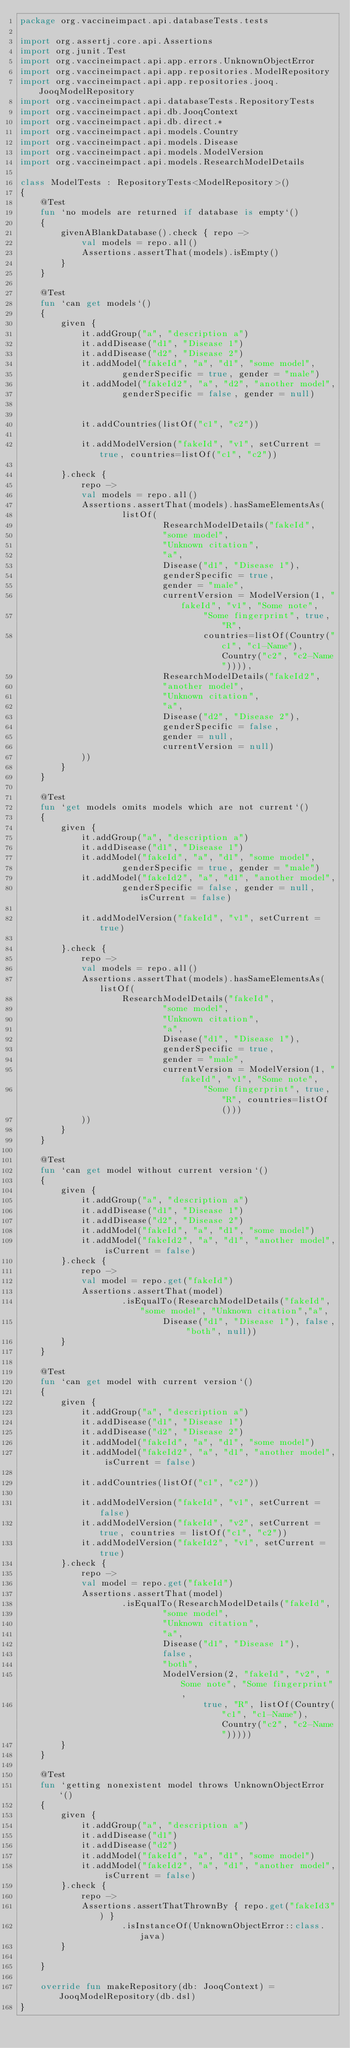<code> <loc_0><loc_0><loc_500><loc_500><_Kotlin_>package org.vaccineimpact.api.databaseTests.tests

import org.assertj.core.api.Assertions
import org.junit.Test
import org.vaccineimpact.api.app.errors.UnknownObjectError
import org.vaccineimpact.api.app.repositories.ModelRepository
import org.vaccineimpact.api.app.repositories.jooq.JooqModelRepository
import org.vaccineimpact.api.databaseTests.RepositoryTests
import org.vaccineimpact.api.db.JooqContext
import org.vaccineimpact.api.db.direct.*
import org.vaccineimpact.api.models.Country
import org.vaccineimpact.api.models.Disease
import org.vaccineimpact.api.models.ModelVersion
import org.vaccineimpact.api.models.ResearchModelDetails

class ModelTests : RepositoryTests<ModelRepository>()
{
    @Test
    fun `no models are returned if database is empty`()
    {
        givenABlankDatabase().check { repo ->
            val models = repo.all()
            Assertions.assertThat(models).isEmpty()
        }
    }

    @Test
    fun `can get models`()
    {
        given {
            it.addGroup("a", "description a")
            it.addDisease("d1", "Disease 1")
            it.addDisease("d2", "Disease 2")
            it.addModel("fakeId", "a", "d1", "some model",
                    genderSpecific = true, gender = "male")
            it.addModel("fakeId2", "a", "d2", "another model",
                    genderSpecific = false, gender = null)


            it.addCountries(listOf("c1", "c2"))

            it.addModelVersion("fakeId", "v1", setCurrent = true, countries=listOf("c1", "c2"))

        }.check {
            repo ->
            val models = repo.all()
            Assertions.assertThat(models).hasSameElementsAs(
                    listOf(
                            ResearchModelDetails("fakeId",
                            "some model",
                            "Unknown citation",
                            "a",
                            Disease("d1", "Disease 1"),
                            genderSpecific = true,
                            gender = "male",
                            currentVersion = ModelVersion(1, "fakeId", "v1", "Some note",
                                    "Some fingerprint", true, "R",
                                    countries=listOf(Country("c1", "c1-Name"), Country("c2", "c2-Name")))),
                            ResearchModelDetails("fakeId2",
                            "another model",
                            "Unknown citation",
                            "a",
                            Disease("d2", "Disease 2"),
                            genderSpecific = false,
                            gender = null,
                            currentVersion = null)
            ))
        }
    }

    @Test
    fun `get models omits models which are not current`()
    {
        given {
            it.addGroup("a", "description a")
            it.addDisease("d1", "Disease 1")
            it.addModel("fakeId", "a", "d1", "some model",
                    genderSpecific = true, gender = "male")
            it.addModel("fakeId2", "a", "d1", "another model",
                    genderSpecific = false, gender = null, isCurrent = false)

            it.addModelVersion("fakeId", "v1", setCurrent = true)

        }.check {
            repo ->
            val models = repo.all()
            Assertions.assertThat(models).hasSameElementsAs(listOf(
                    ResearchModelDetails("fakeId",
                            "some model",
                            "Unknown citation",
                            "a",
                            Disease("d1", "Disease 1"),
                            genderSpecific = true,
                            gender = "male",
                            currentVersion = ModelVersion(1, "fakeId", "v1", "Some note",
                                    "Some fingerprint", true, "R", countries=listOf()))
            ))
        }
    }

    @Test
    fun `can get model without current version`()
    {
        given {
            it.addGroup("a", "description a")
            it.addDisease("d1", "Disease 1")
            it.addDisease("d2", "Disease 2")
            it.addModel("fakeId", "a", "d1", "some model")
            it.addModel("fakeId2", "a", "d1", "another model", isCurrent = false)
        }.check {
            repo ->
            val model = repo.get("fakeId")
            Assertions.assertThat(model)
                    .isEqualTo(ResearchModelDetails("fakeId", "some model", "Unknown citation","a",
                            Disease("d1", "Disease 1"), false, "both", null))
        }
    }

    @Test
    fun `can get model with current version`()
    {
        given {
            it.addGroup("a", "description a")
            it.addDisease("d1", "Disease 1")
            it.addDisease("d2", "Disease 2")
            it.addModel("fakeId", "a", "d1", "some model")
            it.addModel("fakeId2", "a", "d1", "another model", isCurrent = false)

            it.addCountries(listOf("c1", "c2"))

            it.addModelVersion("fakeId", "v1", setCurrent = false)
            it.addModelVersion("fakeId", "v2", setCurrent = true, countries = listOf("c1", "c2"))
            it.addModelVersion("fakeId2", "v1", setCurrent = true)
        }.check {
            repo ->
            val model = repo.get("fakeId")
            Assertions.assertThat(model)
                    .isEqualTo(ResearchModelDetails("fakeId",
                            "some model",
                            "Unknown citation",
                            "a",
                            Disease("d1", "Disease 1"),
                            false,
                            "both",
                            ModelVersion(2, "fakeId", "v2", "Some note", "Some fingerprint",
                                    true, "R", listOf(Country("c1", "c1-Name"), Country("c2", "c2-Name")))))
        }
    }

    @Test
    fun `getting nonexistent model throws UnknownObjectError`()
    {
        given {
            it.addGroup("a", "description a")
            it.addDisease("d1")
            it.addDisease("d2")
            it.addModel("fakeId", "a", "d1", "some model")
            it.addModel("fakeId2", "a", "d1", "another model", isCurrent = false)
        }.check {
            repo ->
            Assertions.assertThatThrownBy { repo.get("fakeId3") }
                    .isInstanceOf(UnknownObjectError::class.java)
        }

    }

    override fun makeRepository(db: JooqContext) = JooqModelRepository(db.dsl)
}</code> 